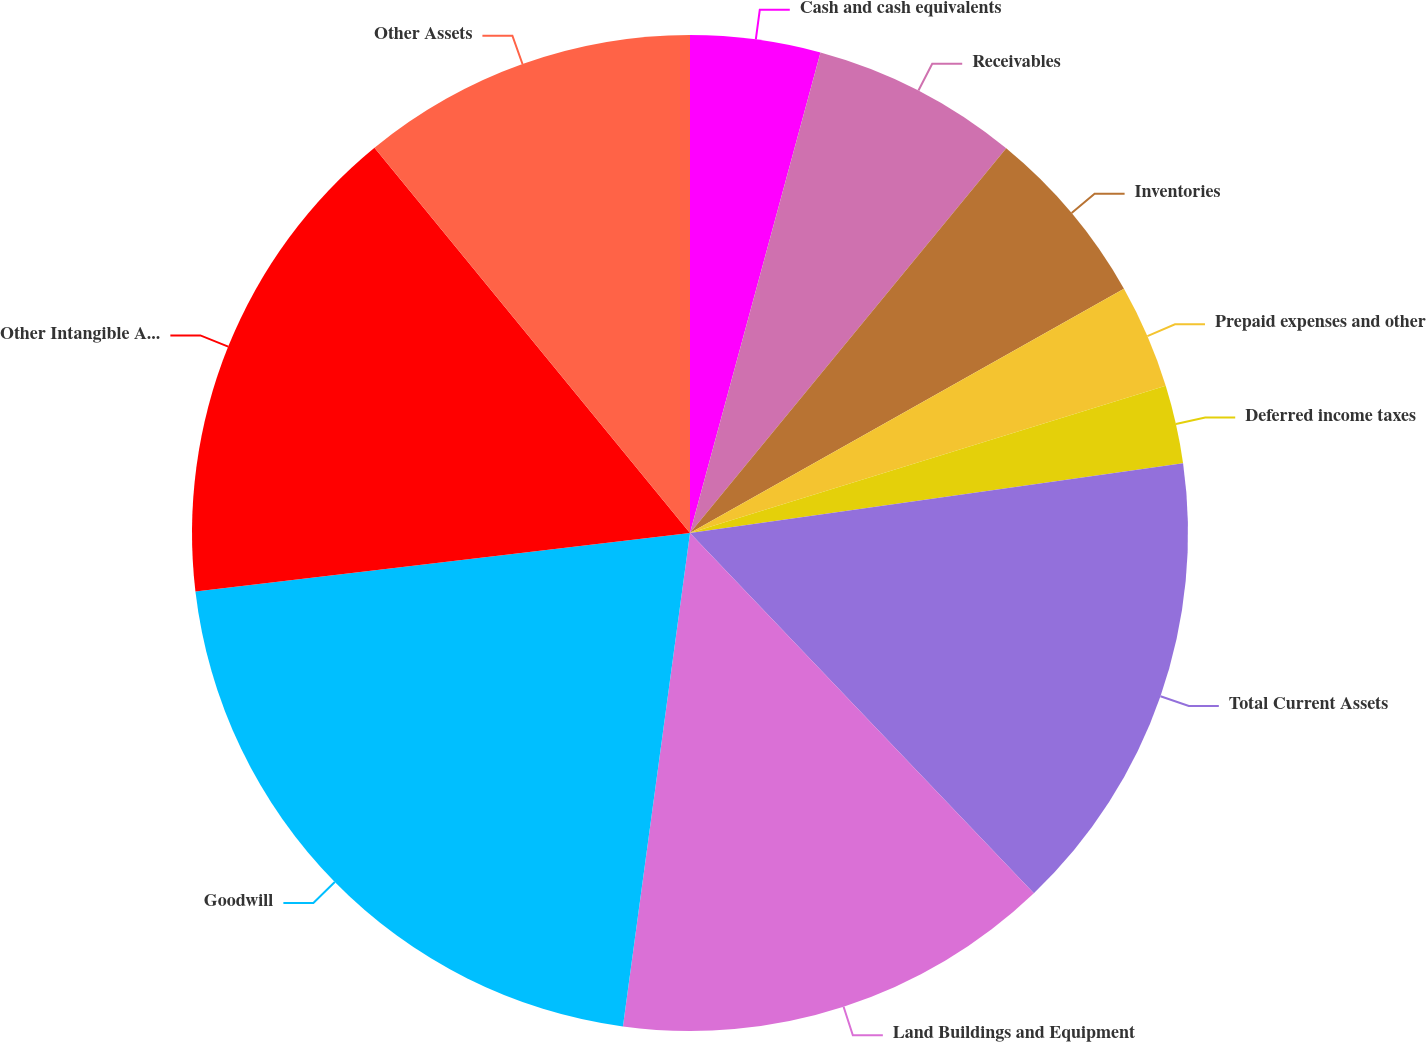Convert chart. <chart><loc_0><loc_0><loc_500><loc_500><pie_chart><fcel>Cash and cash equivalents<fcel>Receivables<fcel>Inventories<fcel>Prepaid expenses and other<fcel>Deferred income taxes<fcel>Total Current Assets<fcel>Land Buildings and Equipment<fcel>Goodwill<fcel>Other Intangible Assets<fcel>Other Assets<nl><fcel>4.22%<fcel>6.73%<fcel>5.89%<fcel>3.38%<fcel>2.54%<fcel>15.11%<fcel>14.28%<fcel>20.98%<fcel>15.95%<fcel>10.92%<nl></chart> 